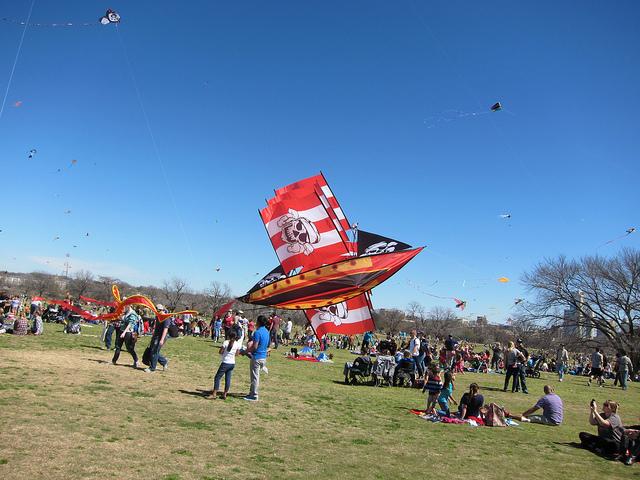Is it crowded?
Quick response, please. Yes. Is this an airplane or kite?
Short answer required. Kite. Is the sky empty?
Short answer required. No. What type day are the people experiencing?
Keep it brief. Sunny. What is in the weather like?
Quick response, please. Sunny. Is this photo taken at the beach?
Quick response, please. No. 